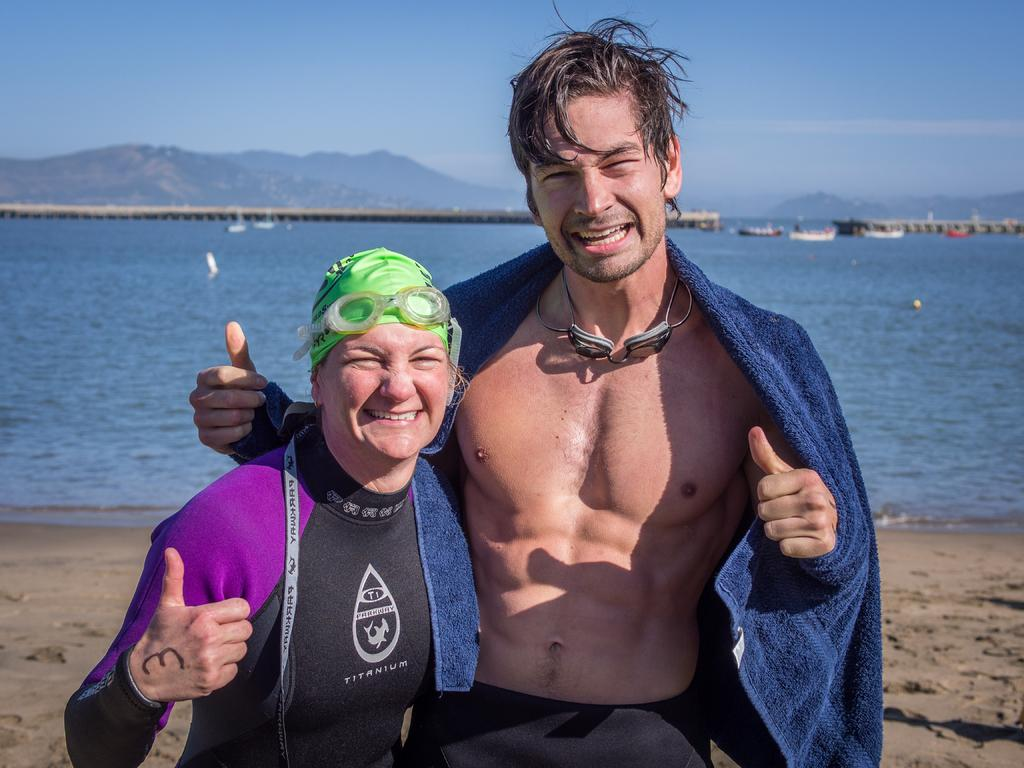How many people are in the image? There are two persons standing on the ground in the image. What can be seen in the background of the image? There are boats on the water and mountains visible in the image. What structure is present in the image? There is a bridge in the image. What part of the natural environment is visible in the image? The sky is visible in the image. What type of net is being used by the maid in the image? There is no maid or net present in the image. How many mountains are visible in the image? The number of mountains visible in the image cannot be determined from the provided facts. 